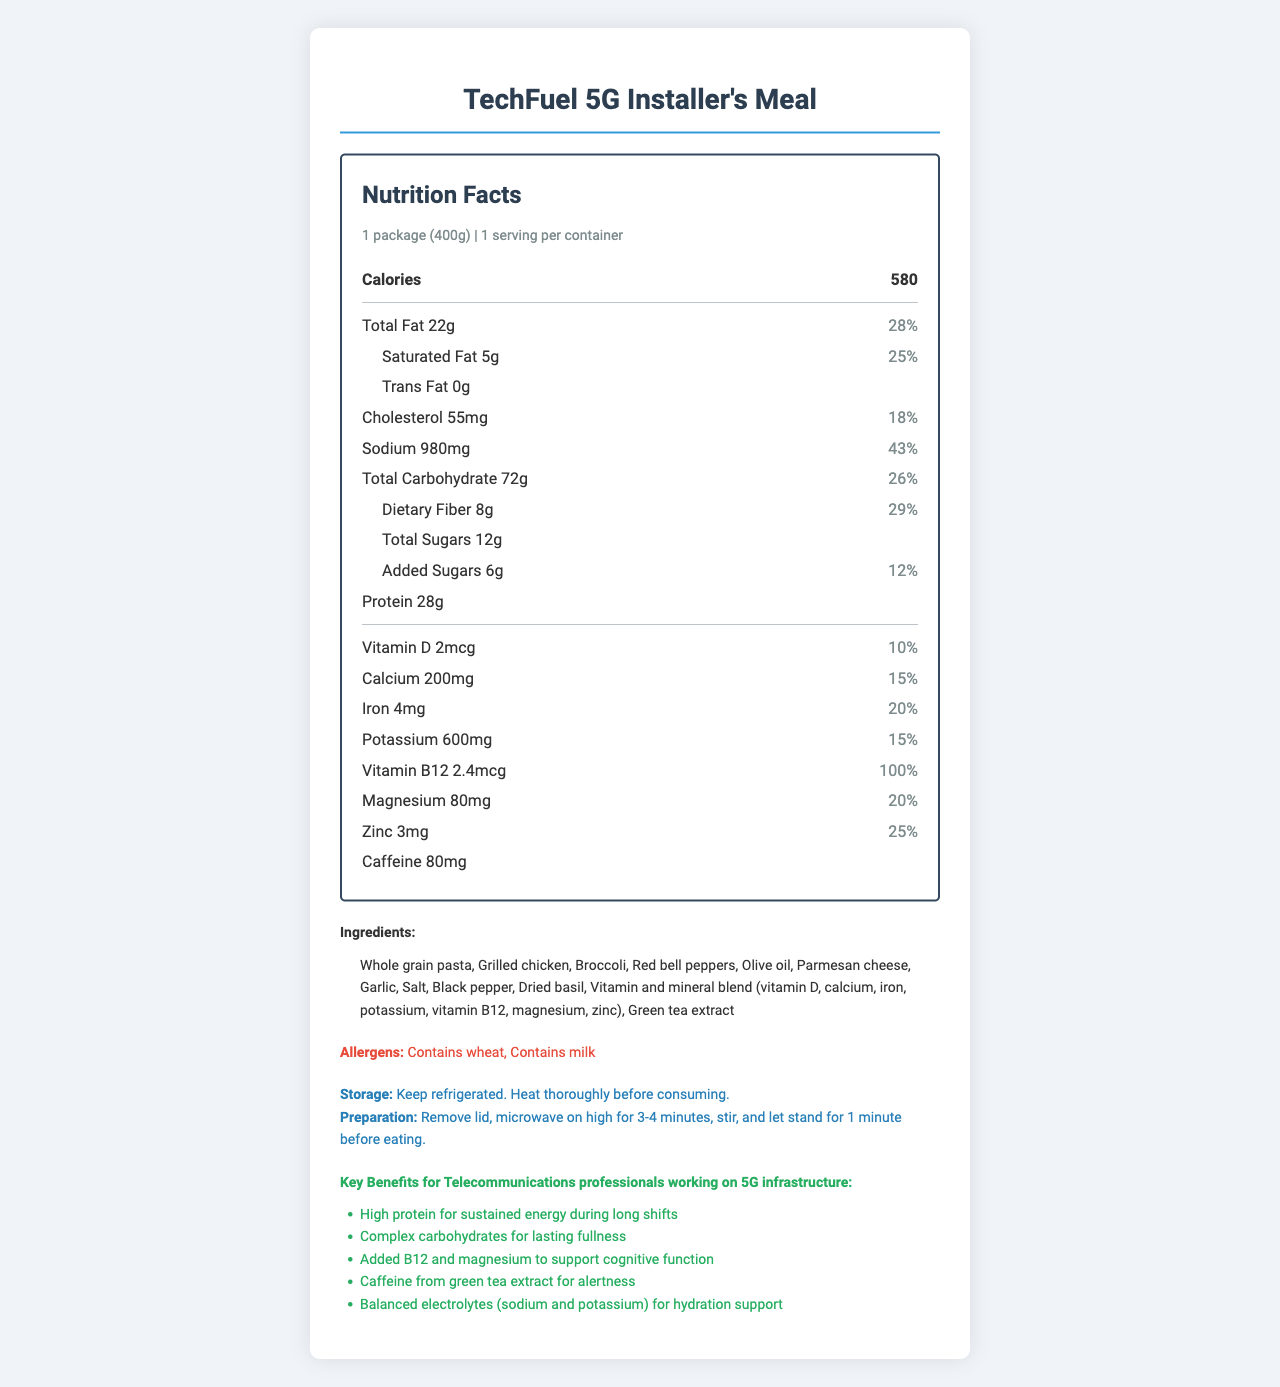How many grams of protein are in the "TechFuel 5G Installer's Meal"? The nutrition label indicates that the meal contains 28g of protein.
Answer: 28g How much sodium does the meal contain? The nutrition label specifies that the meal has 980mg of sodium.
Answer: 980mg What is the serving size of this meal? The serving size is listed as 1 package (400g).
Answer: 1 package (400g) List two key benefits this meal provides for telecommunications professionals working on 5G infrastructure. The key benefits section highlights these advantages.
Answer: High protein for sustained energy during long shifts, Complex carbohydrates for lasting fullness What is the daily value percentage of dietary fiber in this meal? The nutrition label shows that the dietary fiber amount is 29% of the daily value.
Answer: 29% Which ingredient contributes to the caffeine content in the meal? A. Olive oil B. Green tea extract C. Vitamin D D. Parmesan cheese Green tea extract is listed in the ingredients and it contributes to the caffeine content.
Answer: B. Green tea extract Which of the following is a sub-item under total carbohydrates on the label? I. Total Sugars II. Dietary Fiber III. Added Sugars Both Dietary Fiber and Added Sugars are listed as sub-items under total carbohydrates.
Answer: II and III Is the meal suitable for individuals with wheat allergies? The allergens section indicates that the meal contains wheat.
Answer: No Summarize the main nutritional characteristics and key benefits of "TechFuel 5G Installer's Meal". The document provides a comprehensive breakdown of the meal's nutrition facts, including serving size, calorie count, macronutrients, vitamins, and minerals. It also highlights specific benefits for professionals in challenging work environments.
Answer: The "TechFuel 5G Installer's Meal" is a high-calorie, high-protein meal designed for telecommunications professionals working on 5G infrastructure. It provides balanced nutrition with a focus on sustained energy, cognitive support, alertness, and hydration. Key nutrients include 28g of protein, 580 calories, 29% dietary fiber, 100% daily value of vitamin B12, and caffeine from green tea extract. The meal also has significant amounts of electrolytes, vitamins, and minerals. How many milligrams of cholesterol does this meal have? The nutrition label shows that the meal contains 55mg of cholesterol.
Answer: 55mg What are the preparation instructions for this meal? The instructions section details the preparation steps.
Answer: Remove lid, microwave on high for 3-4 minutes, stir, and let stand for 1 minute before eating. What is the main source of complex carbohydrates in this meal? The ingredients list specifies whole grain pasta, which is a source of complex carbohydrates.
Answer: Whole grain pasta How many total grams of fat are in the meal? The nutrition label indicates a total fat content of 22g.
Answer: 22g Which vitamin in this meal contributes 100% of its daily value? The nutrition label lists vitamin B12 as providing 100% of its daily value.
Answer: Vitamin B12 What is the primary benefit of the added B12 and magnesium in this meal? According to the key benefits section, B12 and magnesium support cognitive function.
Answer: Support cognitive function What is the total carbohydrate content of the meal in grams? The nutrition label shows that the total carbohydrate content is 72g.
Answer: 72g What kind of pasta is used in this meal? The ingredients list mentions whole grain pasta.
Answer: Whole grain pasta Does the document provide any information about the cost of the meal? The document does not include any details regarding the cost of the meal.
Answer: Not enough information 